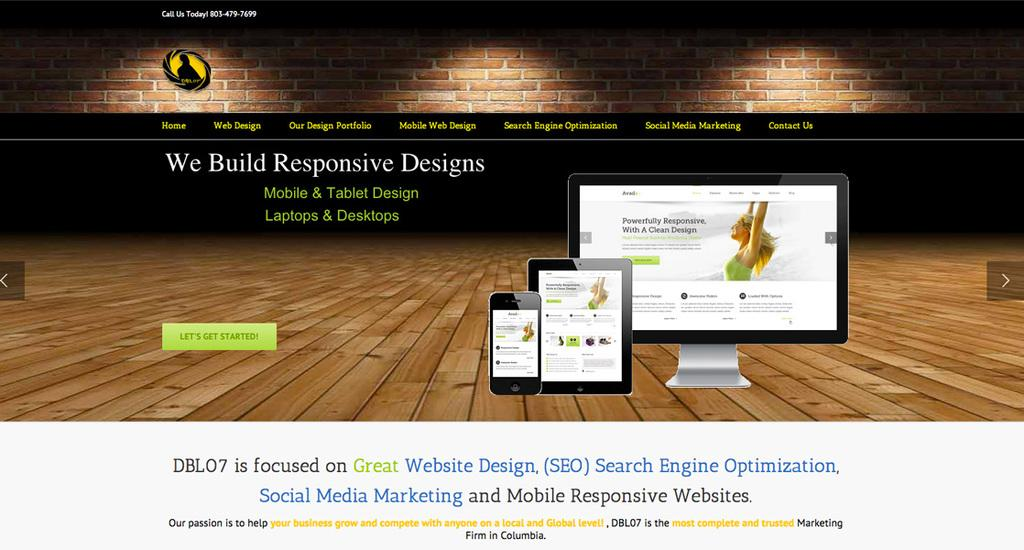What can be found in the image that displays information or messages? There is some text in the image. What electronic device is present in the image? There is a monitor in the image. What type of object is present that can be opened and closed? There is a tab in the image. What type of communication device is present in the image? There is a mobile in the image. What material is the floor made of in the image? The floor in the image is made of wood. What type of wall is visible in the image? The wall in the image has red bricks. Where is some text located in the image? There is some text at the bottom of the image. How many pies are being baked in the image? There are no pies or baking activity present in the image. What type of car is parked in front of the wall in the image? There is no car present in the image; the wall has red bricks. 